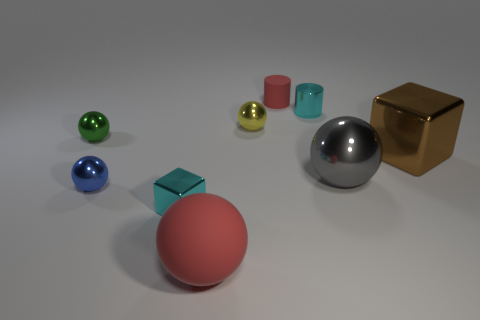Do the blue object on the left side of the large block and the green thing have the same shape?
Give a very brief answer. Yes. Are there more large metallic things to the left of the red sphere than blue metal spheres left of the tiny yellow thing?
Make the answer very short. No. There is a red object that is behind the large rubber object; how many small red matte cylinders are in front of it?
Offer a very short reply. 0. What is the material of the object that is the same color as the small cube?
Your response must be concise. Metal. What number of other objects are there of the same color as the large matte object?
Make the answer very short. 1. There is a tiny cylinder that is behind the small cyan object that is on the right side of the big red rubber thing; what color is it?
Provide a short and direct response. Red. Are there any other spheres that have the same color as the matte ball?
Ensure brevity in your answer.  No. What number of matte objects are either tiny red cubes or large gray balls?
Provide a short and direct response. 0. Is there a yellow cylinder that has the same material as the large gray thing?
Give a very brief answer. No. What number of things are both in front of the small green shiny thing and behind the tiny shiny cube?
Keep it short and to the point. 3. 